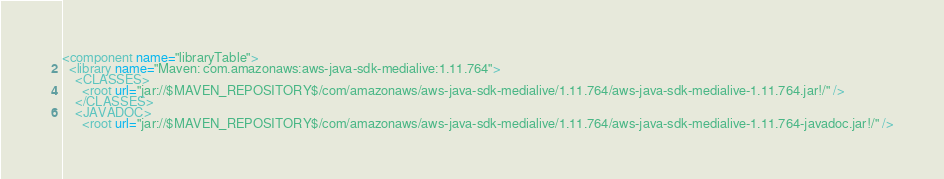Convert code to text. <code><loc_0><loc_0><loc_500><loc_500><_XML_><component name="libraryTable">
  <library name="Maven: com.amazonaws:aws-java-sdk-medialive:1.11.764">
    <CLASSES>
      <root url="jar://$MAVEN_REPOSITORY$/com/amazonaws/aws-java-sdk-medialive/1.11.764/aws-java-sdk-medialive-1.11.764.jar!/" />
    </CLASSES>
    <JAVADOC>
      <root url="jar://$MAVEN_REPOSITORY$/com/amazonaws/aws-java-sdk-medialive/1.11.764/aws-java-sdk-medialive-1.11.764-javadoc.jar!/" /></code> 